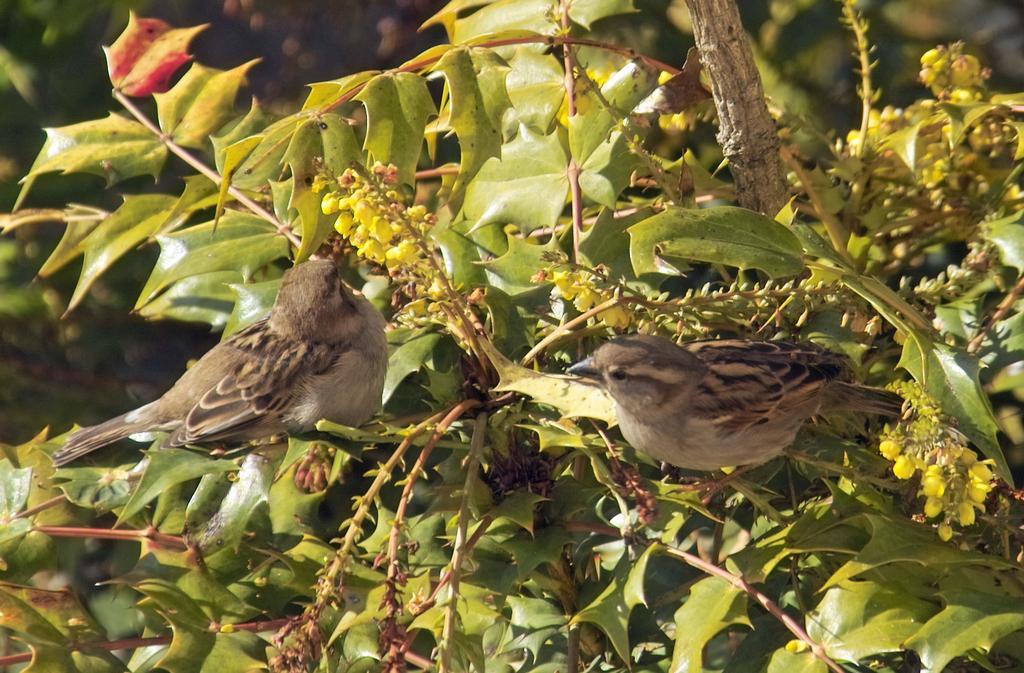Describe this image in one or two sentences. In this picture we can see birds, leaves, stems, branch and buds. In the background of the image it is blurry. 